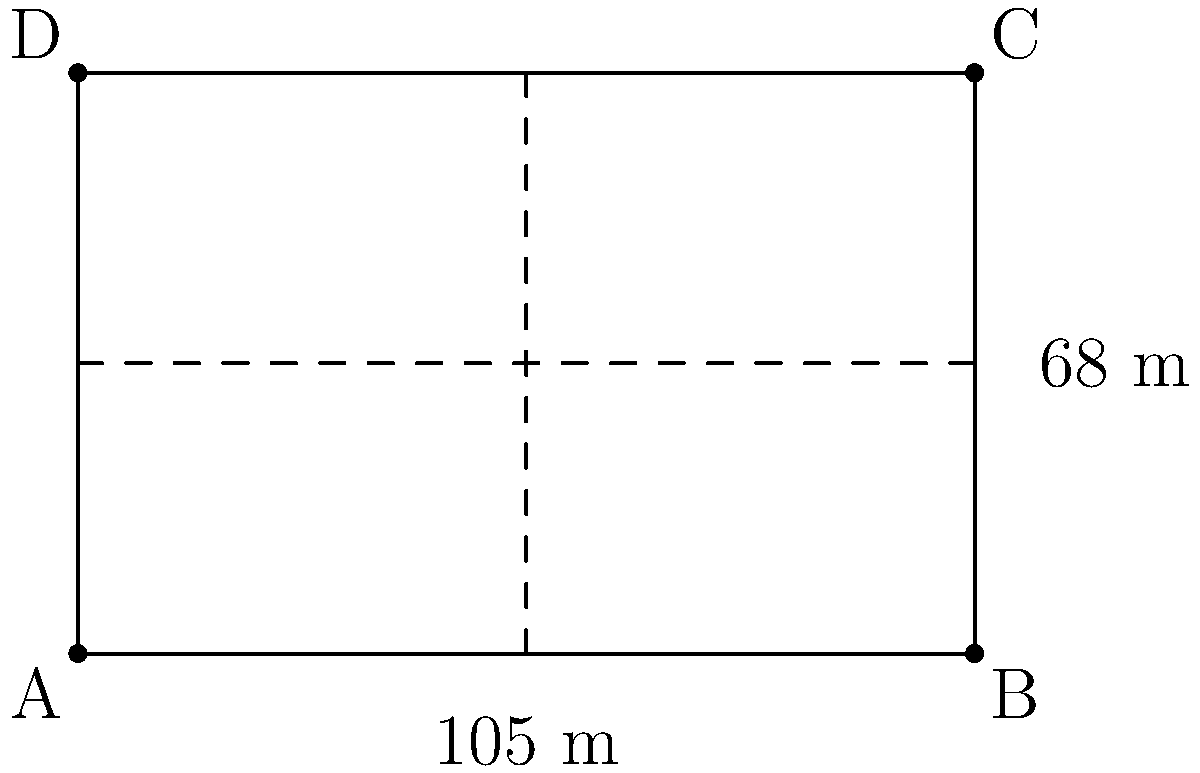As part of a lesson on geometry and sports, you want to calculate the area of a standard soccer field. Given that a soccer field is rectangular with dimensions of 105 meters in length and 68 meters in width, what is the total area of the field in square meters? To calculate the area of a rectangular soccer field, we need to multiply its length by its width. Let's break it down step by step:

1. Identify the given dimensions:
   - Length = 105 meters
   - Width = 68 meters

2. Use the formula for the area of a rectangle:
   $$ \text{Area} = \text{Length} \times \text{Width} $$

3. Substitute the values into the formula:
   $$ \text{Area} = 105 \text{ m} \times 68 \text{ m} $$

4. Perform the multiplication:
   $$ \text{Area} = 7,140 \text{ m}^2 $$

Therefore, the total area of the soccer field is 7,140 square meters.
Answer: 7,140 m² 